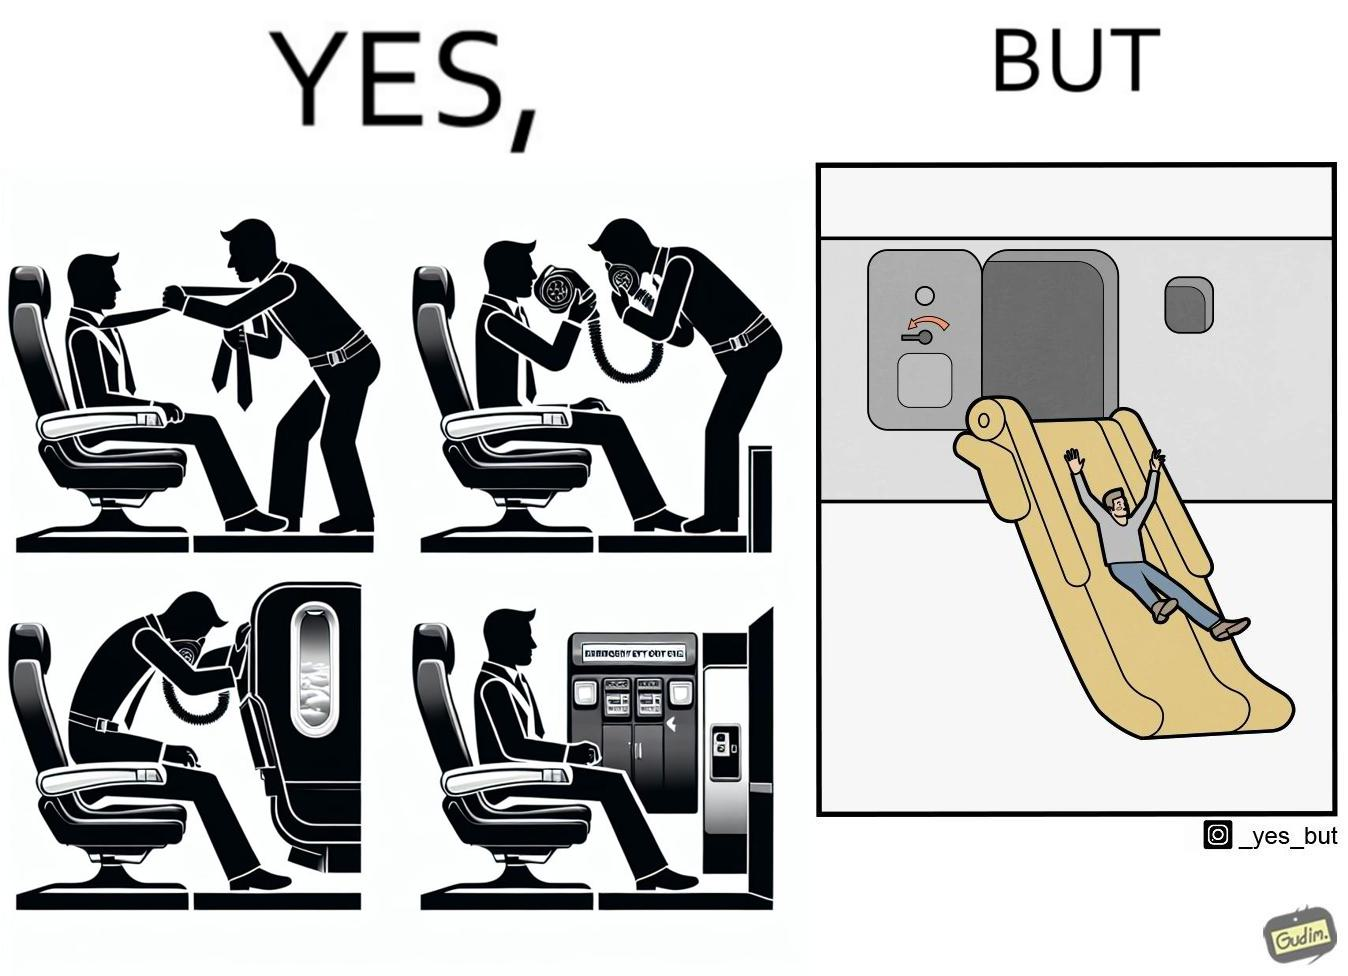What is the satirical meaning behind this image? These images are funny since it shows how we are taught emergency procedures to follow in case of an accident while in an airplane but how none of them work if the plane is still in air 